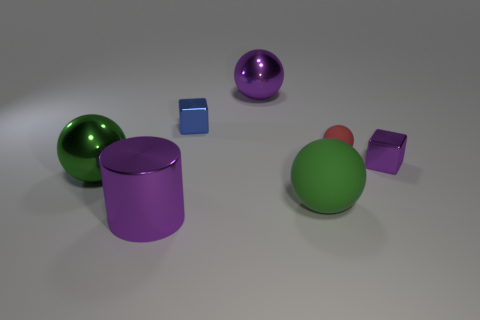How many cylinders are shiny things or tiny blue shiny objects?
Give a very brief answer. 1. How many other large spheres are made of the same material as the red sphere?
Provide a succinct answer. 1. There is a small object that is the same color as the big cylinder; what shape is it?
Your answer should be compact. Cube. There is a large thing that is both in front of the large green metal ball and behind the large purple metal cylinder; what material is it?
Your answer should be very brief. Rubber. What is the shape of the large purple metallic thing that is behind the large rubber object?
Provide a succinct answer. Sphere. What is the shape of the tiny matte object that is in front of the big purple metal object that is on the right side of the purple shiny cylinder?
Make the answer very short. Sphere. Is there another tiny red matte thing that has the same shape as the red rubber thing?
Offer a very short reply. No. There is a red thing that is the same size as the purple cube; what shape is it?
Your answer should be compact. Sphere. Are there any small blue things on the right side of the large ball that is in front of the metal ball that is on the left side of the purple cylinder?
Provide a short and direct response. No. Are there any cylinders that have the same size as the purple metal ball?
Your answer should be very brief. Yes. 